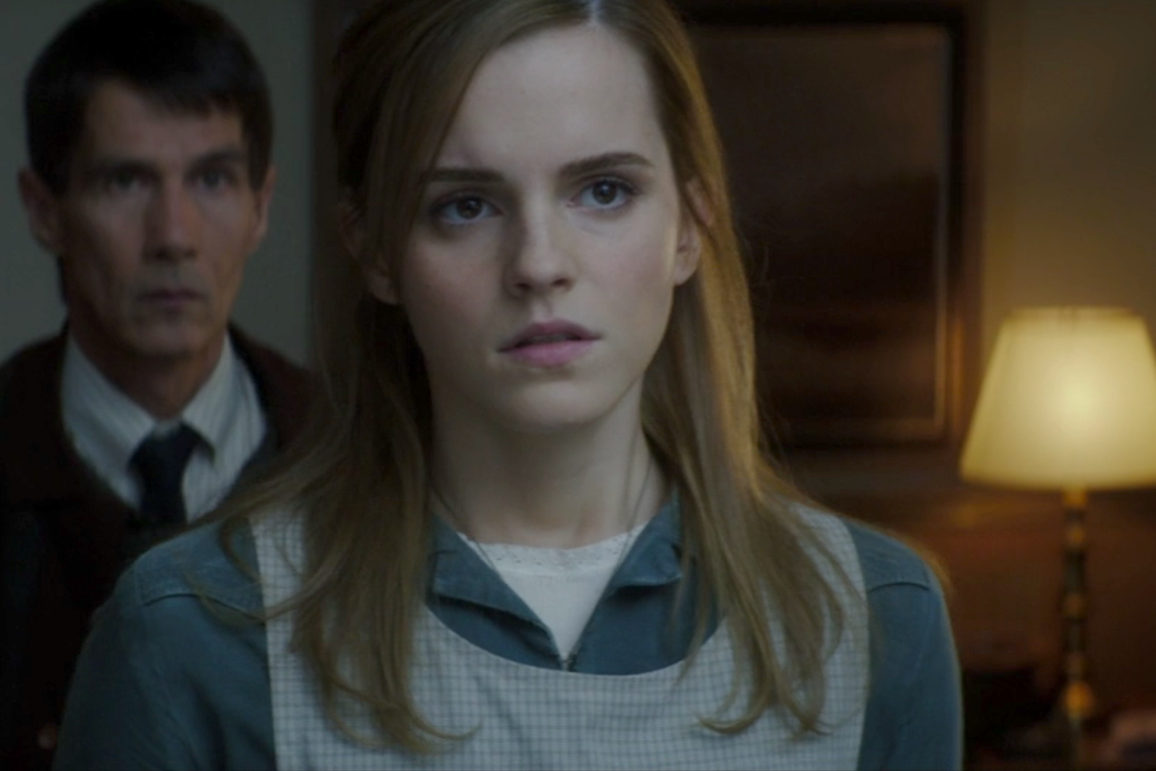Can you describe the main features of this image for me? This image features a woman in the foreground, who appears to be deep in thought or concern, with her eyes wide and slightly to the right. The lighting is dim, casting shadows on her face and enhancing the intensity of her expression. In the background, a man is also visible, positioned behind the woman and mirroring her direction of gaze. The warm glow of a table lamp softly illuminates the room, creating a contrast with the otherwise tense atmosphere. The overall composition and setting suggest this might be a still from a dramatic moment in a film or TV show. 